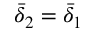Convert formula to latex. <formula><loc_0><loc_0><loc_500><loc_500>\bar { \delta } _ { 2 } = \bar { \delta } _ { 1 }</formula> 